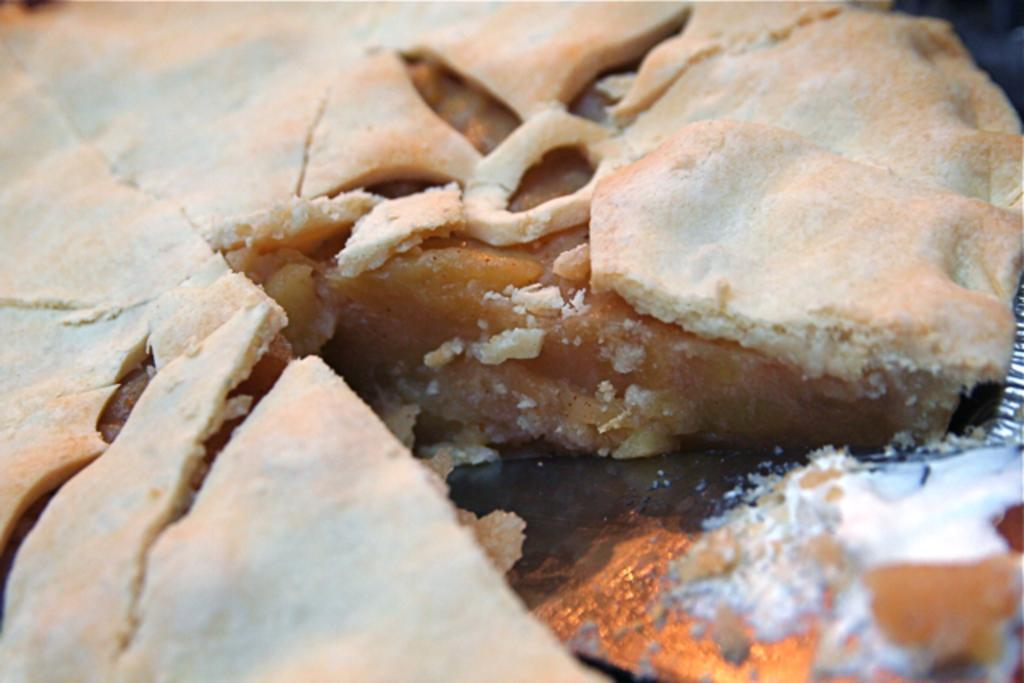What type of object can be seen in the image? The image contains a food item. How many tomatoes can be seen cracking open in the image? There are no tomatoes present in the image, nor is there any indication of them cracking open. 